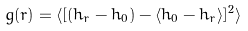Convert formula to latex. <formula><loc_0><loc_0><loc_500><loc_500>g ( r ) = \langle [ ( h _ { r } - h _ { 0 } ) - \langle h _ { 0 } - h _ { r } \rangle ] ^ { 2 } \rangle</formula> 